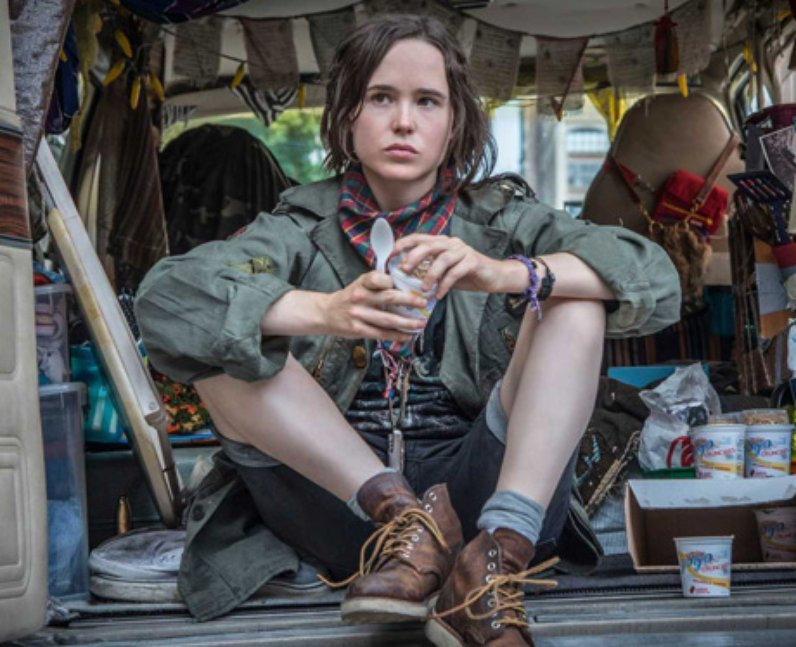What personal traits do you think are essential for someone living in such a van? Living in a van, as shown in the image, likely requires a good deal of adaptability and resourcefulness. The person would need to be independent and self-reliant, capable of handling unexpected situations and making quick decisions on the road. A strong sense of organization is crucial to manage the limited space effectively. Additionally, a positive attitude towards minimalism and a willingness to part with non-essential items would be beneficial. Above all, a sense of adventure and a strong drive to explore new places and meet new people would be essential traits for thriving in such a lifestyle. 